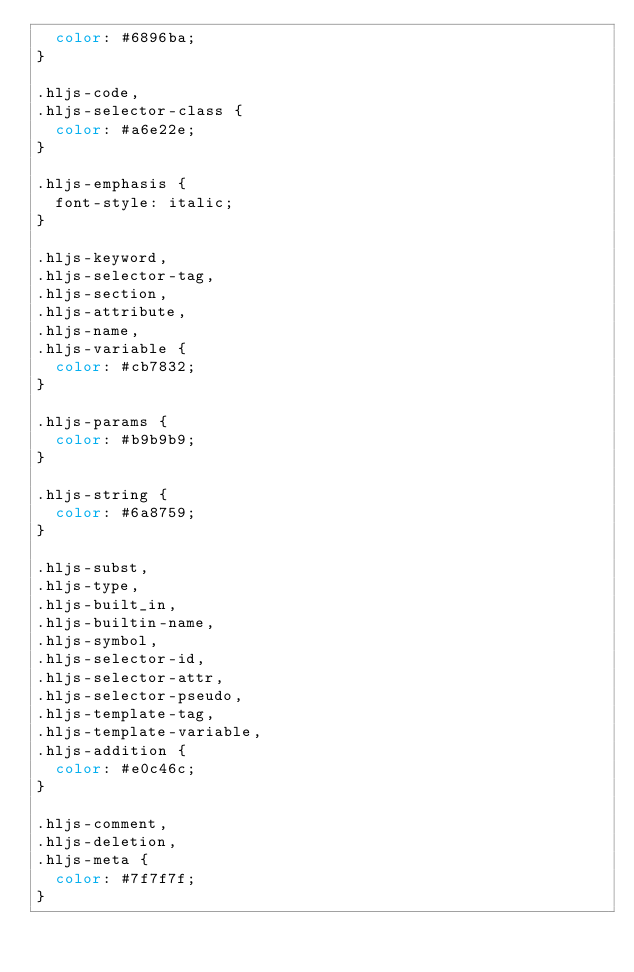Convert code to text. <code><loc_0><loc_0><loc_500><loc_500><_CSS_>  color: #6896ba;
}

.hljs-code,
.hljs-selector-class {
  color: #a6e22e;
}

.hljs-emphasis {
  font-style: italic;
}

.hljs-keyword,
.hljs-selector-tag,
.hljs-section,
.hljs-attribute,
.hljs-name,
.hljs-variable {
  color: #cb7832;
}

.hljs-params {
  color: #b9b9b9;
}

.hljs-string {
  color: #6a8759;
}

.hljs-subst,
.hljs-type,
.hljs-built_in,
.hljs-builtin-name,
.hljs-symbol,
.hljs-selector-id,
.hljs-selector-attr,
.hljs-selector-pseudo,
.hljs-template-tag,
.hljs-template-variable,
.hljs-addition {
  color: #e0c46c;
}

.hljs-comment,
.hljs-deletion,
.hljs-meta {
  color: #7f7f7f;
}
</code> 